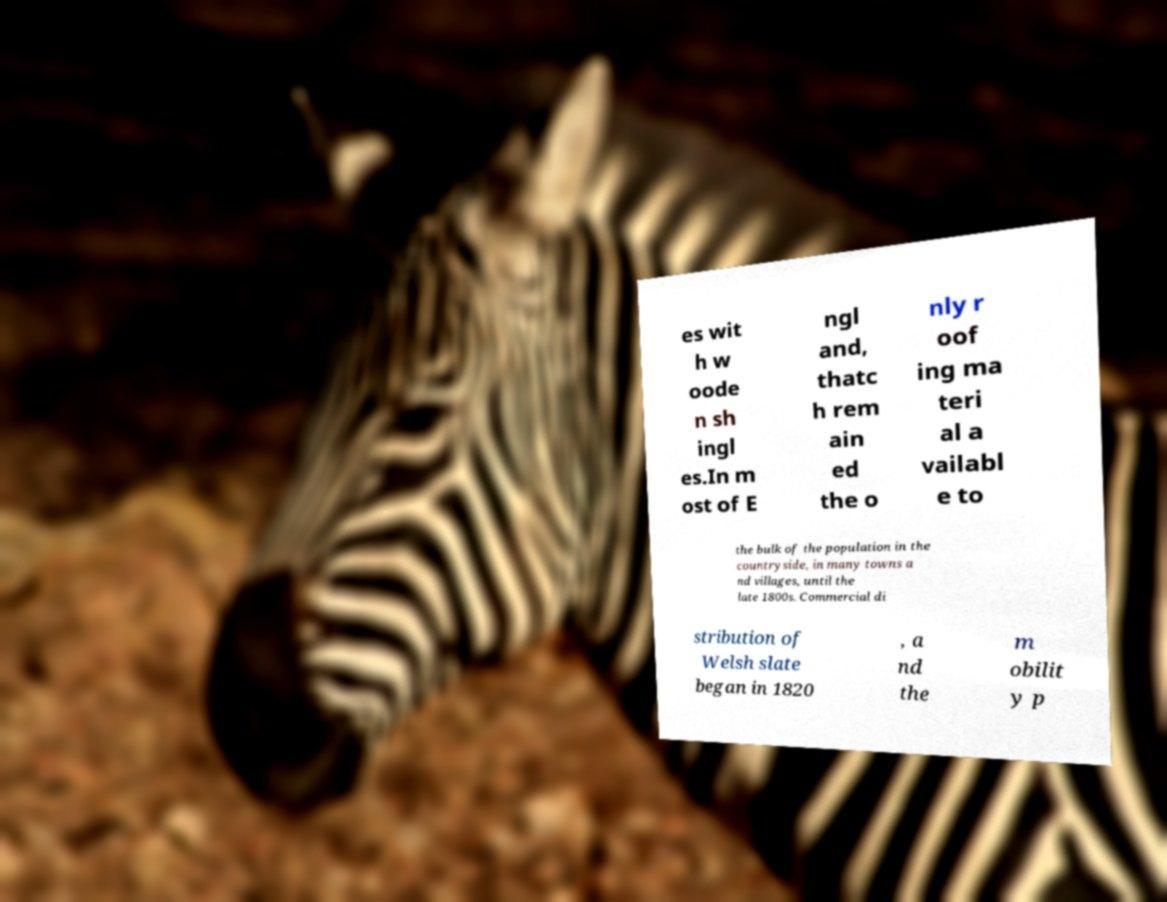I need the written content from this picture converted into text. Can you do that? es wit h w oode n sh ingl es.In m ost of E ngl and, thatc h rem ain ed the o nly r oof ing ma teri al a vailabl e to the bulk of the population in the countryside, in many towns a nd villages, until the late 1800s. Commercial di stribution of Welsh slate began in 1820 , a nd the m obilit y p 